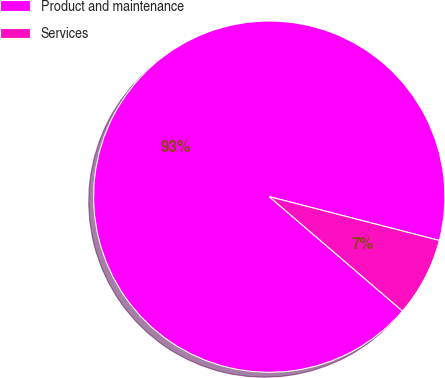Convert chart. <chart><loc_0><loc_0><loc_500><loc_500><pie_chart><fcel>Product and maintenance<fcel>Services<nl><fcel>92.72%<fcel>7.28%<nl></chart> 